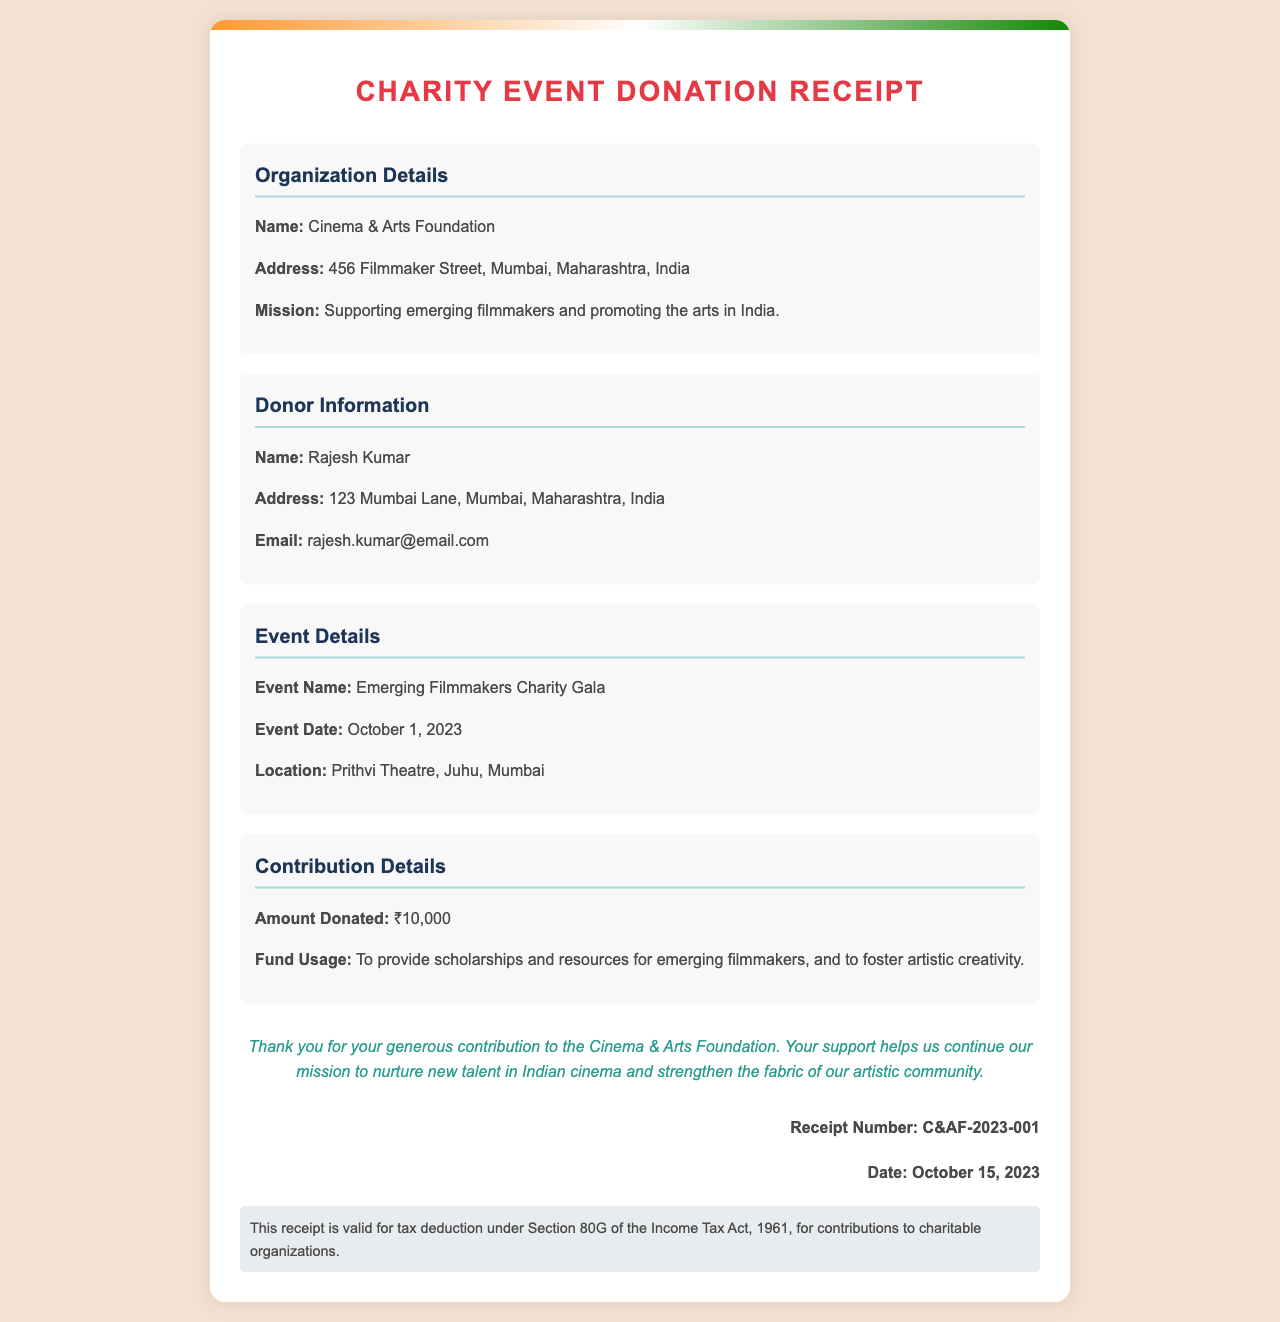What is the name of the organization? The organization name is mentioned clearly in the document under "Organization Details."
Answer: Cinema & Arts Foundation Who is the donor? The donor's name is located in the "Donor Information" section of the document.
Answer: Rajesh Kumar What is the event date? The date of the event can be found in the "Event Details" section.
Answer: October 1, 2023 How much was donated? The donation amount is specified in the "Contribution Details" part of the document.
Answer: ₹10,000 What is the receipt number? The receipt number is presented at the bottom of the document, indicating a unique identification for this donation.
Answer: C&AF-2023-001 What is the mission of the organization? The mission statement is provided in the "Organization Details" section, summarizing the organization's purpose.
Answer: Supporting emerging filmmakers and promoting the arts in India Where was the event held? The location of the event is specified in the "Event Details" section of the receipt.
Answer: Prithvi Theatre, Juhu, Mumbai What section of the Income Tax Act is mentioned for tax deduction? This information is provided in the "Tax Info" section of the receipt.
Answer: Section 80G 